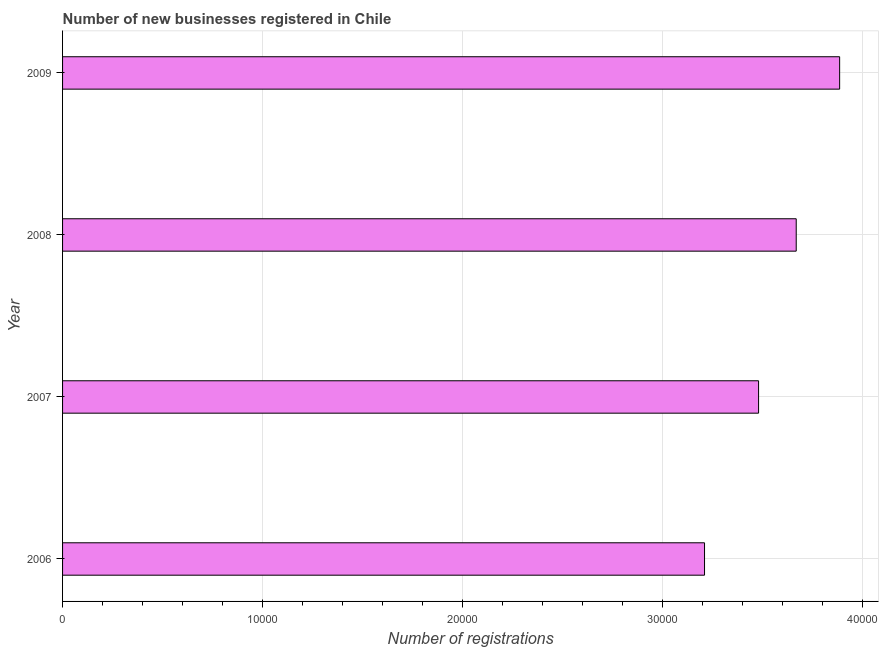Does the graph contain grids?
Provide a succinct answer. Yes. What is the title of the graph?
Give a very brief answer. Number of new businesses registered in Chile. What is the label or title of the X-axis?
Your answer should be very brief. Number of registrations. What is the number of new business registrations in 2009?
Provide a short and direct response. 3.89e+04. Across all years, what is the maximum number of new business registrations?
Give a very brief answer. 3.89e+04. Across all years, what is the minimum number of new business registrations?
Your answer should be very brief. 3.21e+04. What is the sum of the number of new business registrations?
Provide a short and direct response. 1.42e+05. What is the difference between the number of new business registrations in 2006 and 2008?
Give a very brief answer. -4586. What is the average number of new business registrations per year?
Offer a terse response. 3.56e+04. What is the median number of new business registrations?
Keep it short and to the point. 3.58e+04. What is the ratio of the number of new business registrations in 2006 to that in 2007?
Provide a succinct answer. 0.92. Is the number of new business registrations in 2006 less than that in 2007?
Make the answer very short. Yes. What is the difference between the highest and the second highest number of new business registrations?
Keep it short and to the point. 2172. Is the sum of the number of new business registrations in 2007 and 2008 greater than the maximum number of new business registrations across all years?
Ensure brevity in your answer.  Yes. What is the difference between the highest and the lowest number of new business registrations?
Make the answer very short. 6758. In how many years, is the number of new business registrations greater than the average number of new business registrations taken over all years?
Provide a short and direct response. 2. How many bars are there?
Your response must be concise. 4. What is the Number of registrations in 2006?
Your answer should be compact. 3.21e+04. What is the Number of registrations in 2007?
Your answer should be very brief. 3.48e+04. What is the Number of registrations in 2008?
Give a very brief answer. 3.67e+04. What is the Number of registrations in 2009?
Make the answer very short. 3.89e+04. What is the difference between the Number of registrations in 2006 and 2007?
Offer a very short reply. -2703. What is the difference between the Number of registrations in 2006 and 2008?
Your response must be concise. -4586. What is the difference between the Number of registrations in 2006 and 2009?
Your response must be concise. -6758. What is the difference between the Number of registrations in 2007 and 2008?
Offer a very short reply. -1883. What is the difference between the Number of registrations in 2007 and 2009?
Provide a succinct answer. -4055. What is the difference between the Number of registrations in 2008 and 2009?
Offer a terse response. -2172. What is the ratio of the Number of registrations in 2006 to that in 2007?
Provide a succinct answer. 0.92. What is the ratio of the Number of registrations in 2006 to that in 2009?
Give a very brief answer. 0.83. What is the ratio of the Number of registrations in 2007 to that in 2008?
Ensure brevity in your answer.  0.95. What is the ratio of the Number of registrations in 2007 to that in 2009?
Your answer should be very brief. 0.9. What is the ratio of the Number of registrations in 2008 to that in 2009?
Provide a succinct answer. 0.94. 